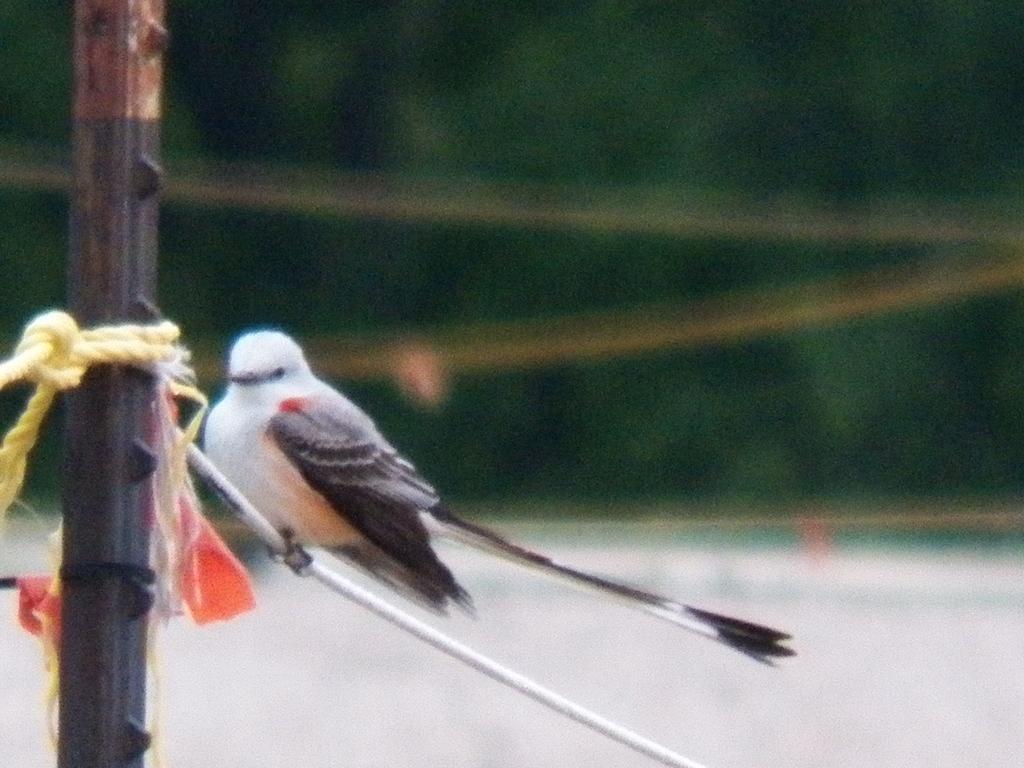Can you describe this image briefly? In this image, we can see a bird on a white colored object. We can see a pole, a rope and some cloth. We can also see the blurred background. 